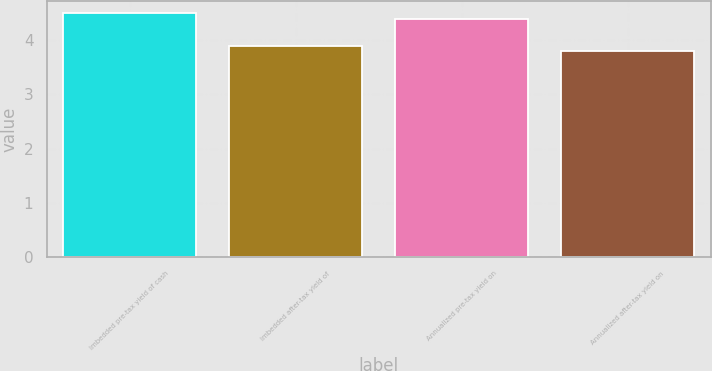Convert chart. <chart><loc_0><loc_0><loc_500><loc_500><bar_chart><fcel>Imbedded pre-tax yield of cash<fcel>Imbedded after-tax yield of<fcel>Annualized pre-tax yield on<fcel>Annualized after-tax yield on<nl><fcel>4.5<fcel>3.9<fcel>4.4<fcel>3.8<nl></chart> 